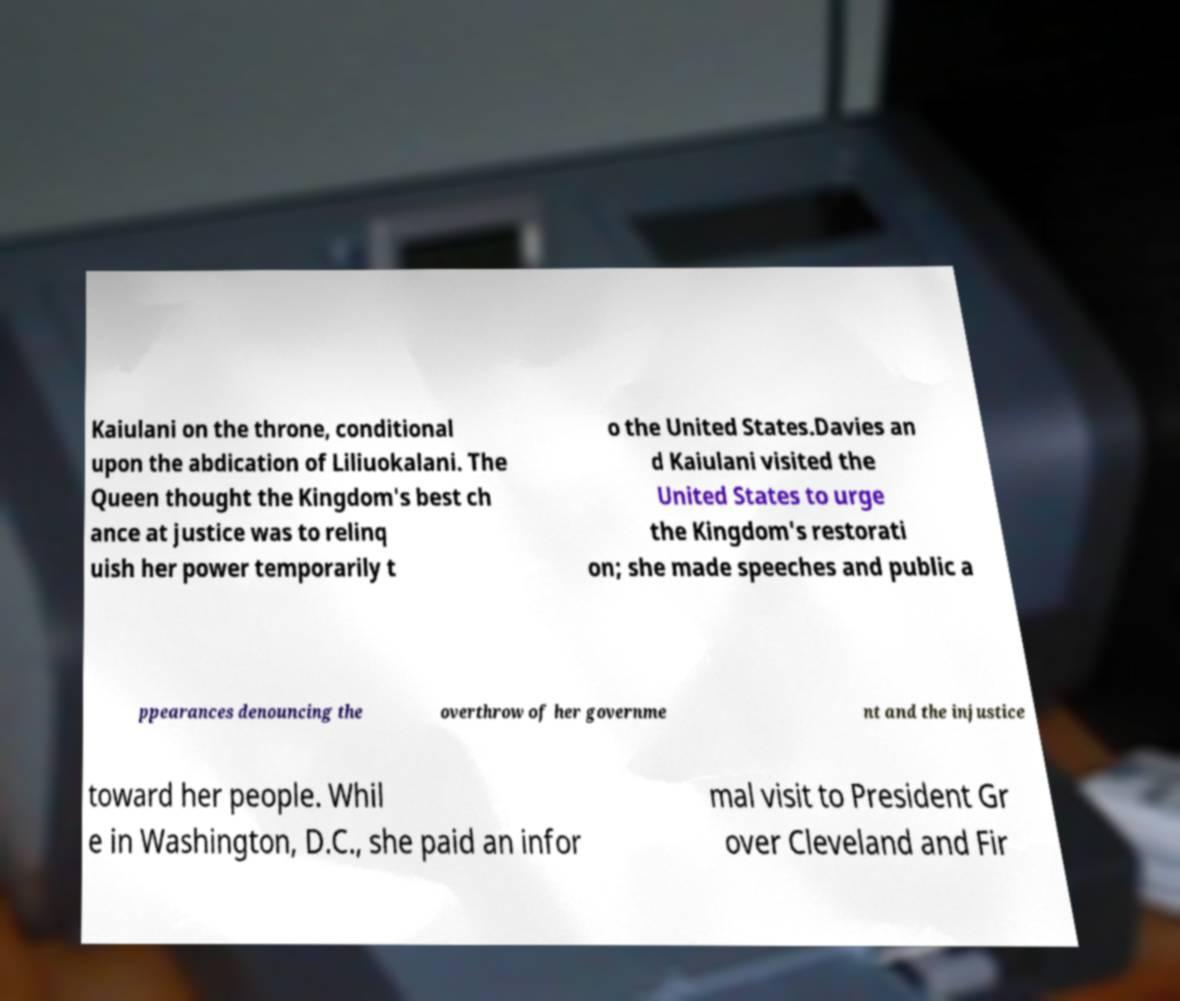Could you assist in decoding the text presented in this image and type it out clearly? Kaiulani on the throne, conditional upon the abdication of Liliuokalani. The Queen thought the Kingdom's best ch ance at justice was to relinq uish her power temporarily t o the United States.Davies an d Kaiulani visited the United States to urge the Kingdom's restorati on; she made speeches and public a ppearances denouncing the overthrow of her governme nt and the injustice toward her people. Whil e in Washington, D.C., she paid an infor mal visit to President Gr over Cleveland and Fir 